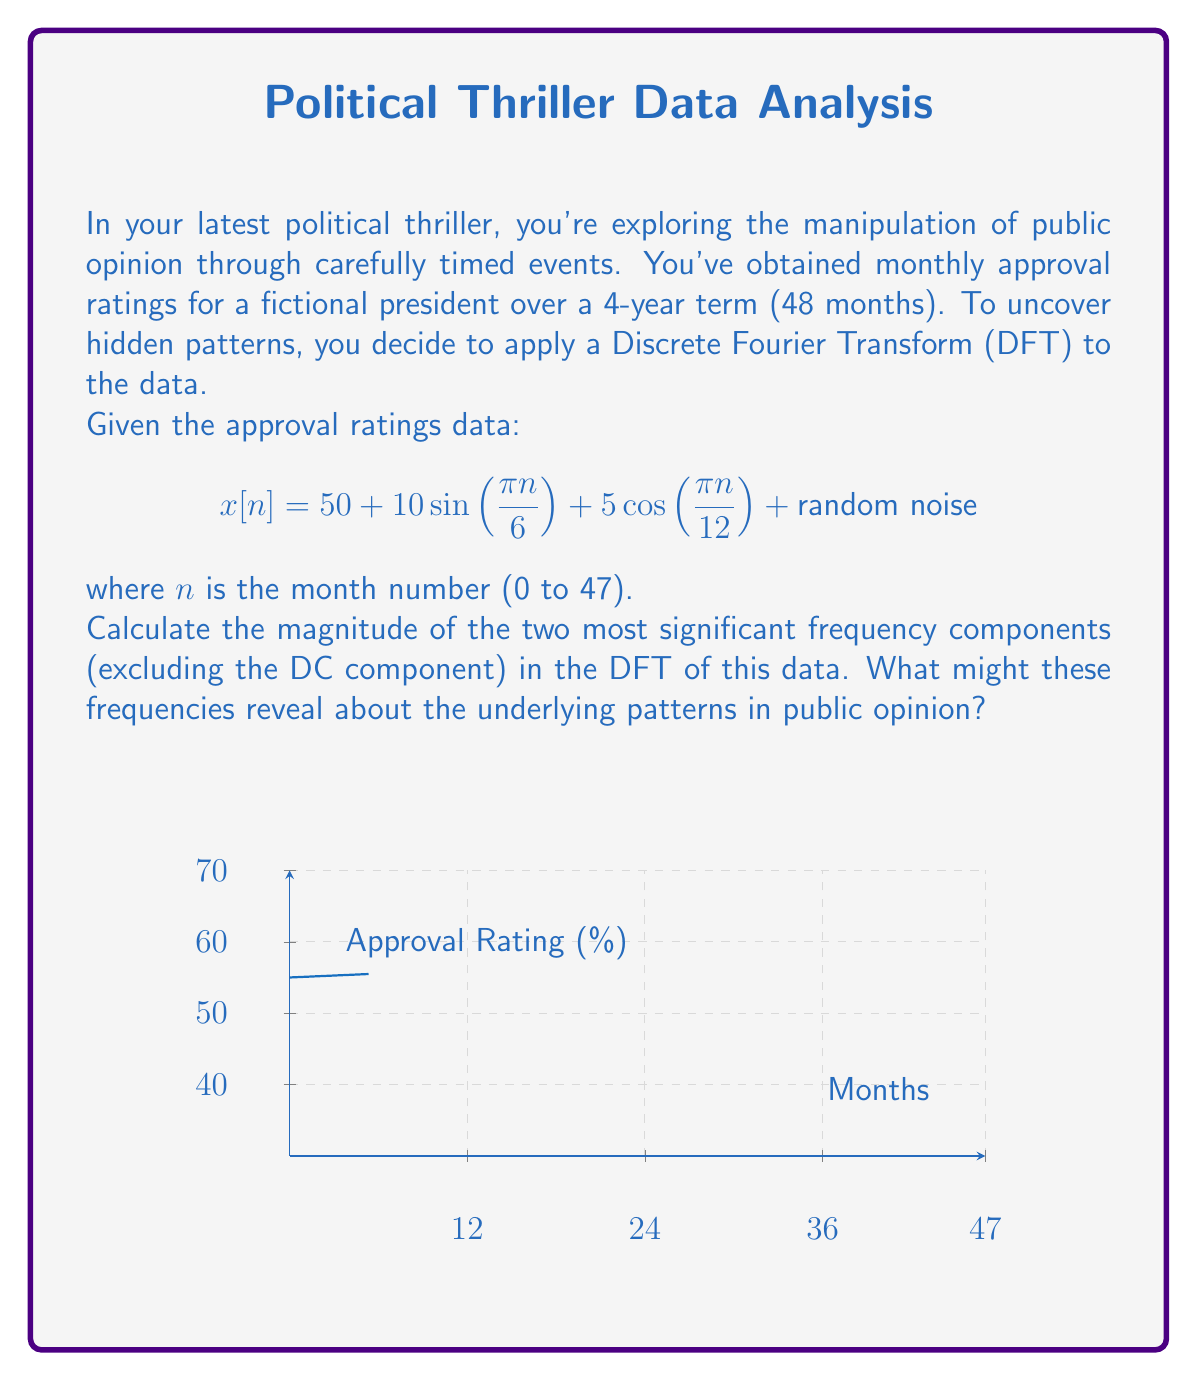Can you solve this math problem? Let's approach this step-by-step:

1) The given function has two sinusoidal components:
   - $10\sin(\frac{\pi n}{6})$ with period 12 months
   - $5\cos(\frac{\pi n}{12})$ with period 24 months

2) For a DFT of a 48-month sequence, the frequency resolution is $\frac{1}{48}$ cycles per month.

3) The frequencies we expect to see are:
   - $f_1 = \frac{1}{12} = 0.0833$ cycles/month (12-month period)
   - $f_2 = \frac{1}{24} = 0.0417$ cycles/month (24-month period)

4) These correspond to DFT bins:
   - $k_1 = f_1 \times 48 = 4$
   - $k_2 = f_2 \times 48 = 2$

5) The magnitude of each component in the DFT will be proportional to its amplitude in the time domain:
   - For $10\sin(\frac{\pi n}{6})$: $|X[4]| \approx 10 \times \frac{48}{2} = 240$
   - For $5\cos(\frac{\pi n}{12})$: $|X[2]| \approx 5 \times \frac{48}{2} = 120$

6) The DC component ($k=0$) will have a magnitude of approximately $50 \times 48 = 2400$, but we're excluding this as per the question.

7) Interpretation: 
   - The 12-month cycle (frequency $\frac{1}{12}$) suggests an annual pattern in approval ratings, possibly tied to yearly events or seasons.
   - The 24-month cycle (frequency $\frac{1}{24}$) might indicate a biennial pattern, perhaps related to election cycles or major policy implementations.

These patterns could be crucial plot elements in a political thriller, suggesting deliberate manipulation of public opinion on regular cycles.
Answer: $|X[4]| \approx 240$, $|X[2]| \approx 120$; Annual and biennial cycles in approval ratings. 